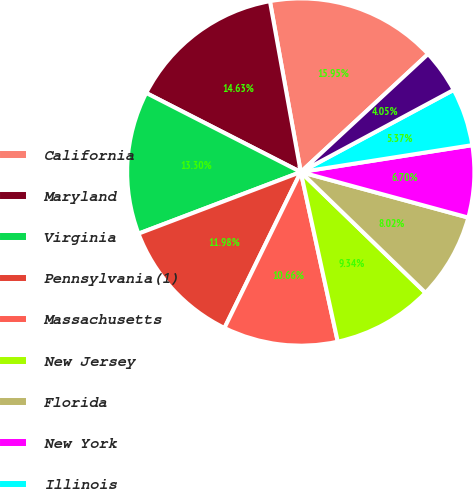<chart> <loc_0><loc_0><loc_500><loc_500><pie_chart><fcel>California<fcel>Maryland<fcel>Virginia<fcel>Pennsylvania(1)<fcel>Massachusetts<fcel>New Jersey<fcel>Florida<fcel>New York<fcel>Illinois<fcel>Connecticut<nl><fcel>15.95%<fcel>14.63%<fcel>13.3%<fcel>11.98%<fcel>10.66%<fcel>9.34%<fcel>8.02%<fcel>6.7%<fcel>5.37%<fcel>4.05%<nl></chart> 